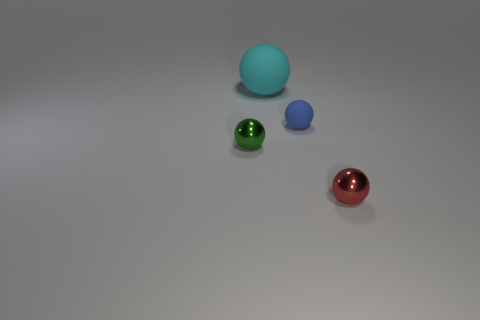Are there any big blue matte things of the same shape as the cyan rubber thing?
Your response must be concise. No. There is a big rubber object; does it have the same shape as the metallic thing that is behind the small red metal thing?
Your answer should be compact. Yes. How big is the thing that is to the left of the blue rubber thing and in front of the cyan rubber ball?
Make the answer very short. Small. How many small rubber objects are there?
Your answer should be very brief. 1. What material is the red ball that is the same size as the blue matte object?
Your answer should be very brief. Metal. Is there a red metallic thing of the same size as the cyan object?
Provide a succinct answer. No. Is the color of the small sphere to the left of the big cyan thing the same as the big matte object that is to the left of the small red sphere?
Offer a very short reply. No. How many rubber objects are either cyan things or blue balls?
Offer a very short reply. 2. How many red shiny things are to the left of the rubber sphere behind the matte thing right of the large rubber ball?
Make the answer very short. 0. The thing that is the same material as the tiny green sphere is what size?
Keep it short and to the point. Small. 